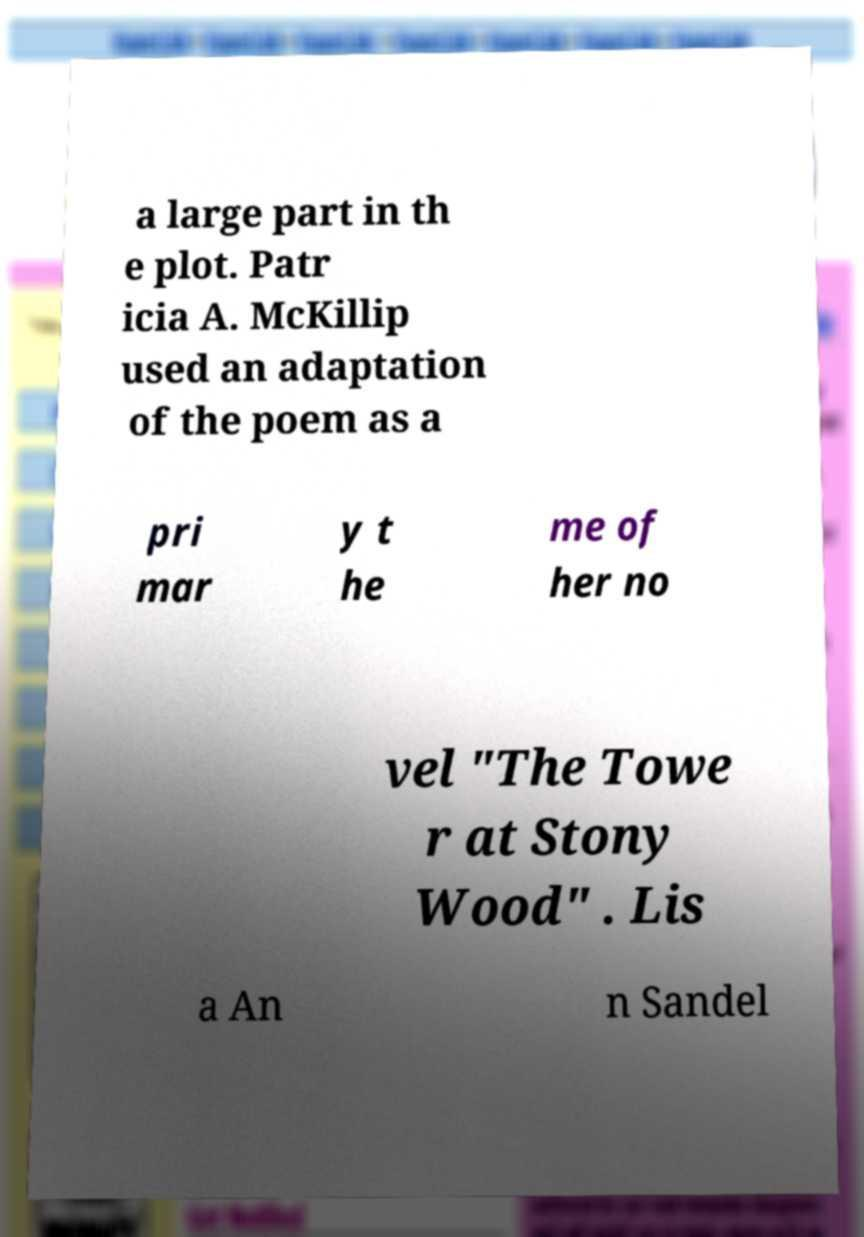Please read and relay the text visible in this image. What does it say? a large part in th e plot. Patr icia A. McKillip used an adaptation of the poem as a pri mar y t he me of her no vel "The Towe r at Stony Wood" . Lis a An n Sandel 